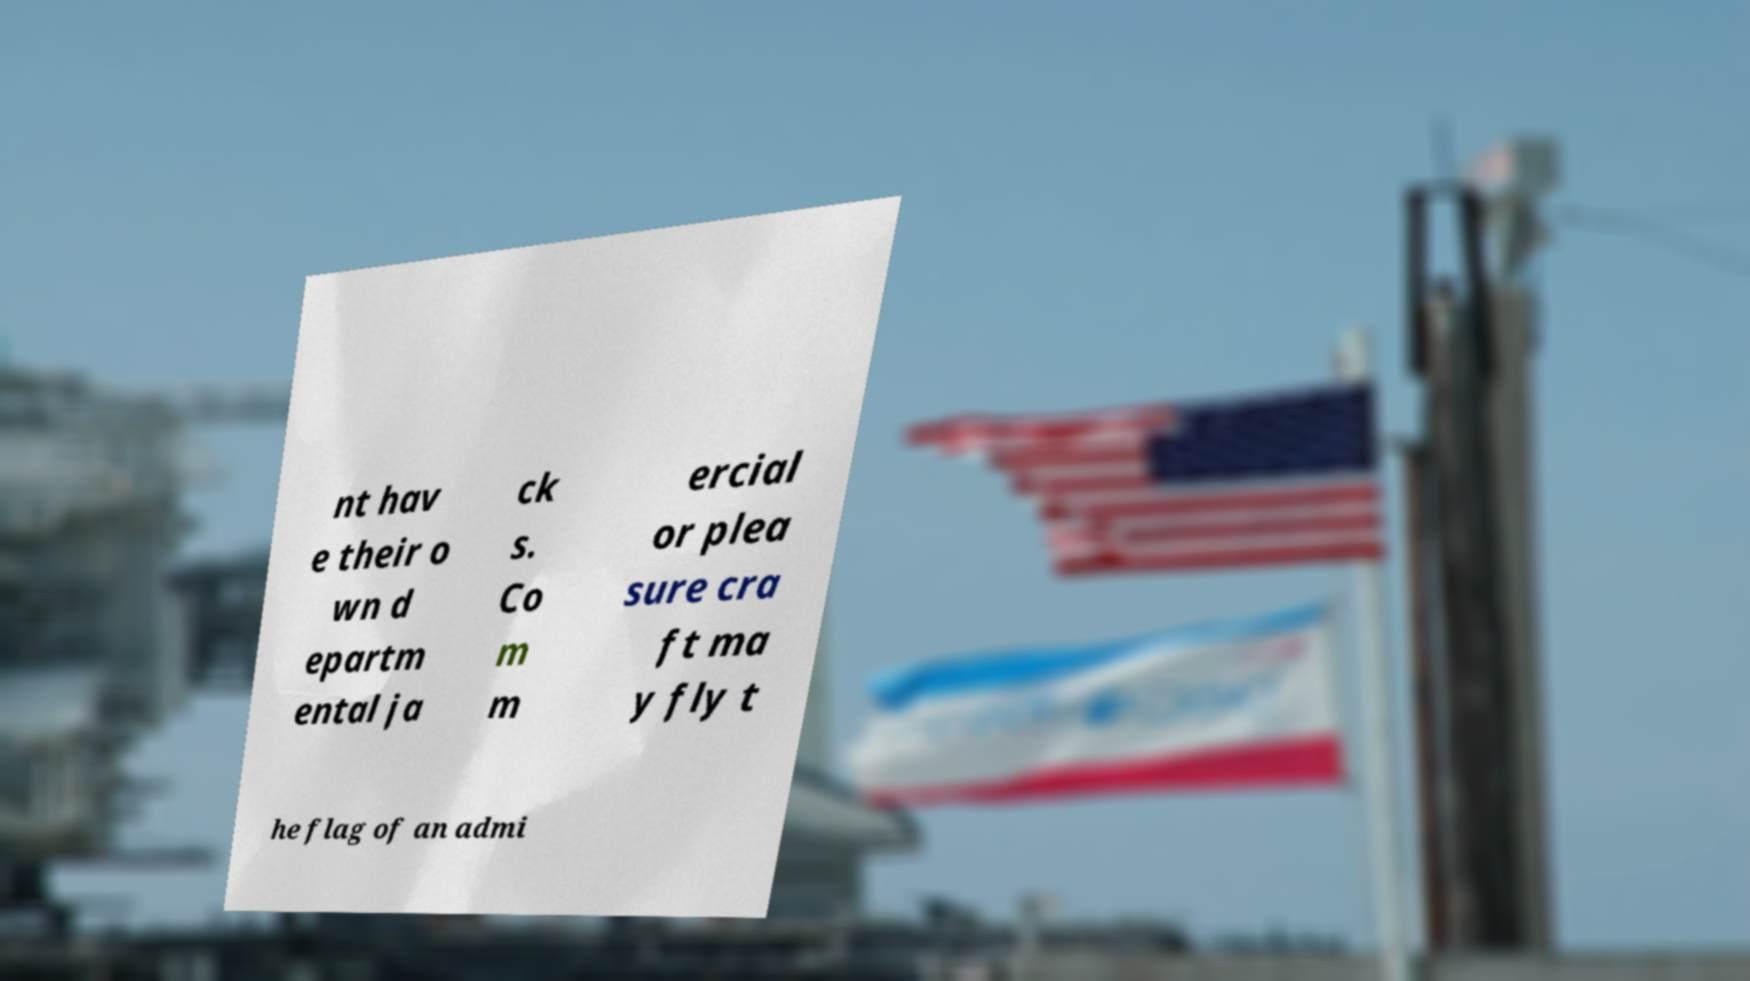Could you assist in decoding the text presented in this image and type it out clearly? nt hav e their o wn d epartm ental ja ck s. Co m m ercial or plea sure cra ft ma y fly t he flag of an admi 